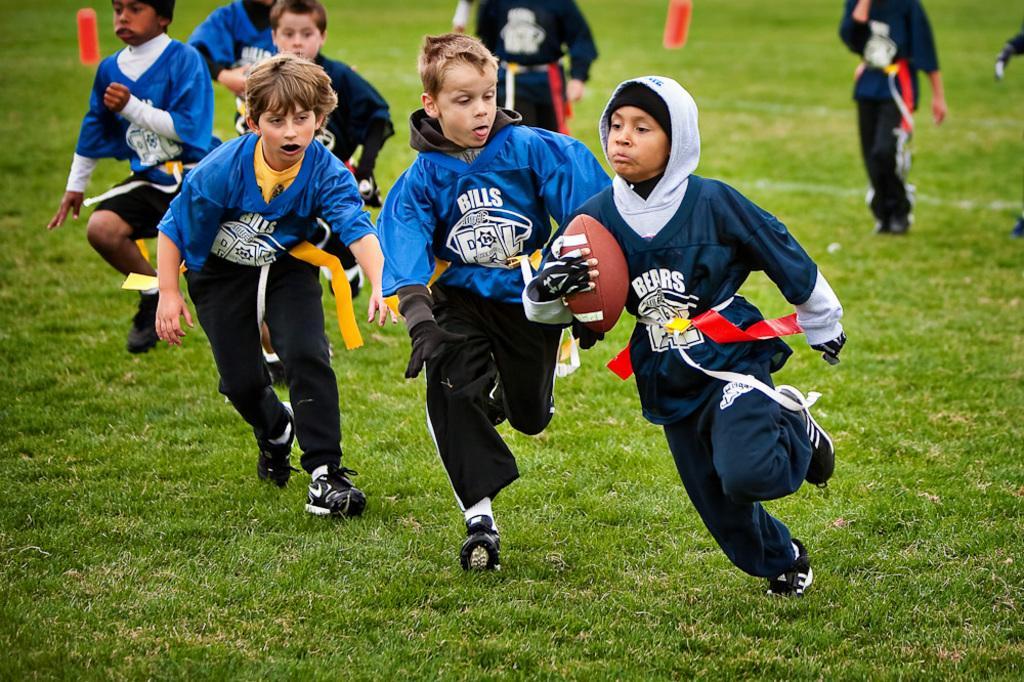Describe this image in one or two sentences. In this picture we can see a group of boys where one is holding ball in his hand and they are running on ground and some are standing. 